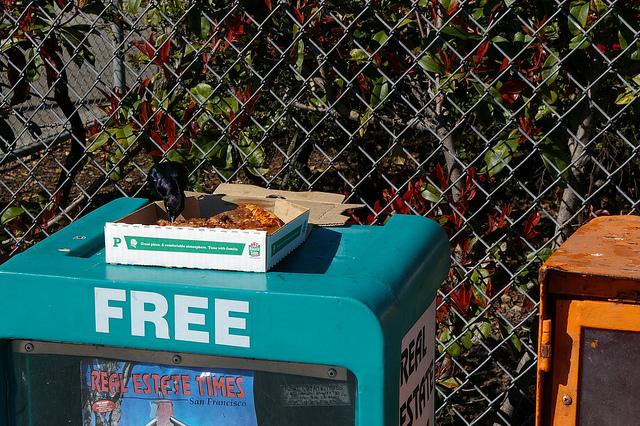Is there a fence in the photo?
Be succinct. Yes. What type of newspaper is the pizza on top of?
Short answer required. Real estate times. What color bird is eating the pizza?
Quick response, please. Black. 